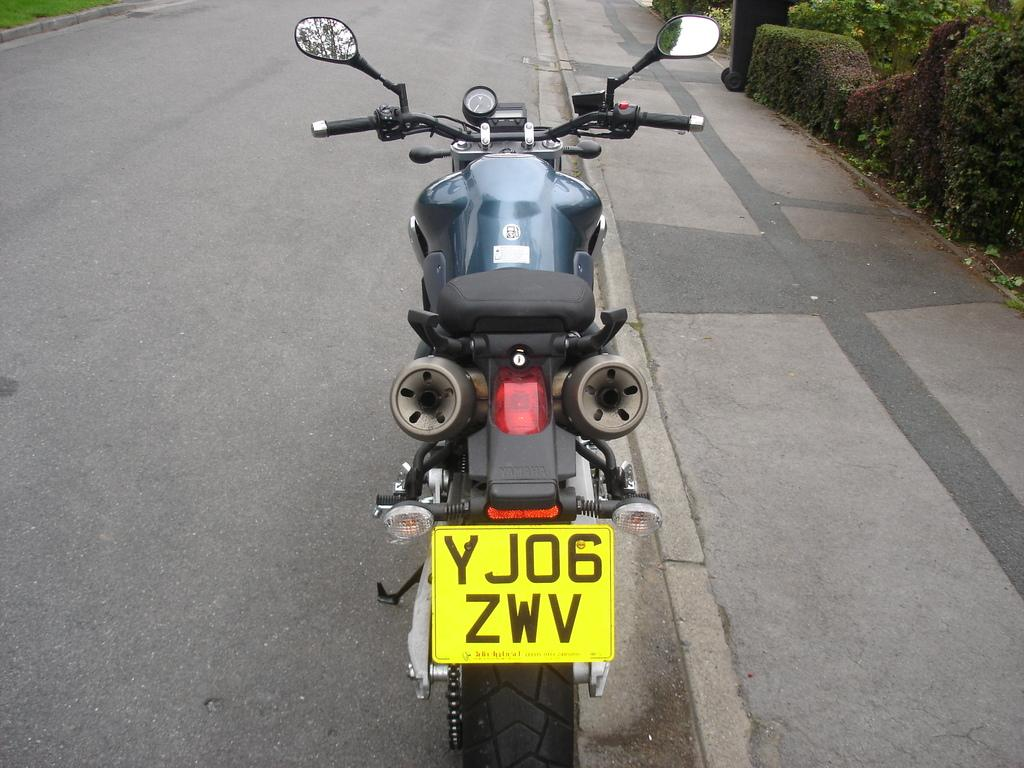What is there is a bike in the image, can you describe its position? The bike is in front of the picture. What can be seen at the bottom of the image? There is a road visible at the bottom of the image. What type of vegetation is present in the right top of the image? Trees and shrubs are present in the right top of the image. Is the moon visible in the image, and what type of heat does it emit? The moon is not visible in the image, and it does not emit any heat. 